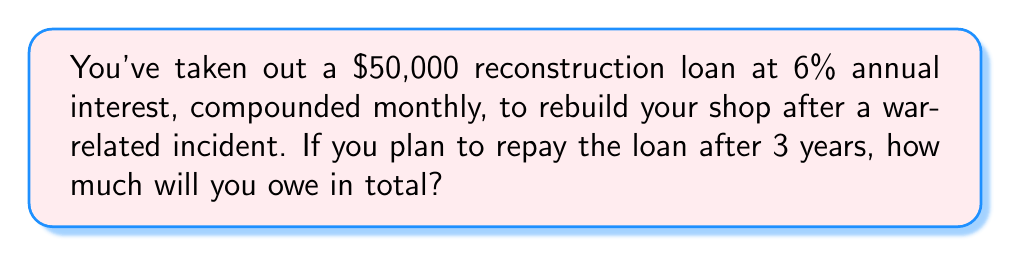Could you help me with this problem? To solve this problem, we'll use the compound interest formula:

$$A = P(1 + \frac{r}{n})^{nt}$$

Where:
$A$ = Final amount
$P$ = Principal (initial loan amount)
$r$ = Annual interest rate (as a decimal)
$n$ = Number of times interest is compounded per year
$t$ = Number of years

Given:
$P = 50,000$
$r = 0.06$ (6% as a decimal)
$n = 12$ (compounded monthly)
$t = 3$ years

Let's substitute these values into the formula:

$$A = 50,000(1 + \frac{0.06}{12})^{12 \cdot 3}$$

$$A = 50,000(1 + 0.005)^{36}$$

$$A = 50,000(1.005)^{36}$$

Using a calculator:

$$A = 50,000 \cdot 1.1972$$

$$A = 59,860.00$$
Answer: $59,860.00 